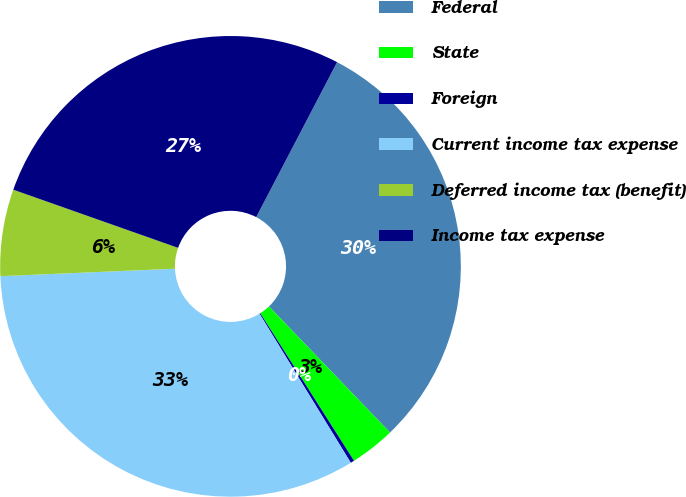Convert chart to OTSL. <chart><loc_0><loc_0><loc_500><loc_500><pie_chart><fcel>Federal<fcel>State<fcel>Foreign<fcel>Current income tax expense<fcel>Deferred income tax (benefit)<fcel>Income tax expense<nl><fcel>30.17%<fcel>3.17%<fcel>0.26%<fcel>33.07%<fcel>6.08%<fcel>27.26%<nl></chart> 